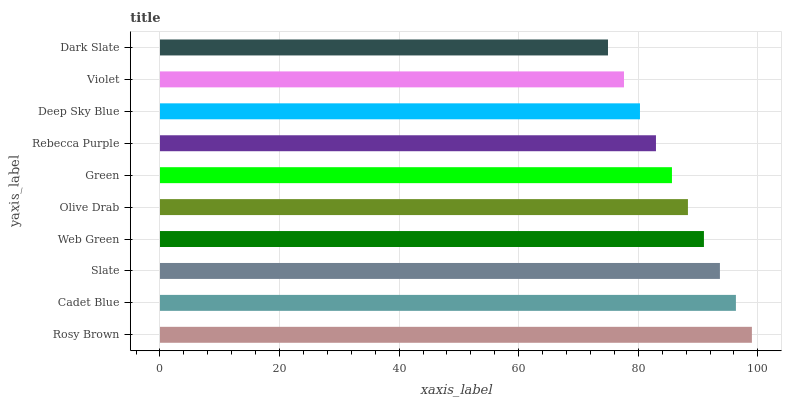Is Dark Slate the minimum?
Answer yes or no. Yes. Is Rosy Brown the maximum?
Answer yes or no. Yes. Is Cadet Blue the minimum?
Answer yes or no. No. Is Cadet Blue the maximum?
Answer yes or no. No. Is Rosy Brown greater than Cadet Blue?
Answer yes or no. Yes. Is Cadet Blue less than Rosy Brown?
Answer yes or no. Yes. Is Cadet Blue greater than Rosy Brown?
Answer yes or no. No. Is Rosy Brown less than Cadet Blue?
Answer yes or no. No. Is Olive Drab the high median?
Answer yes or no. Yes. Is Green the low median?
Answer yes or no. Yes. Is Rosy Brown the high median?
Answer yes or no. No. Is Rebecca Purple the low median?
Answer yes or no. No. 